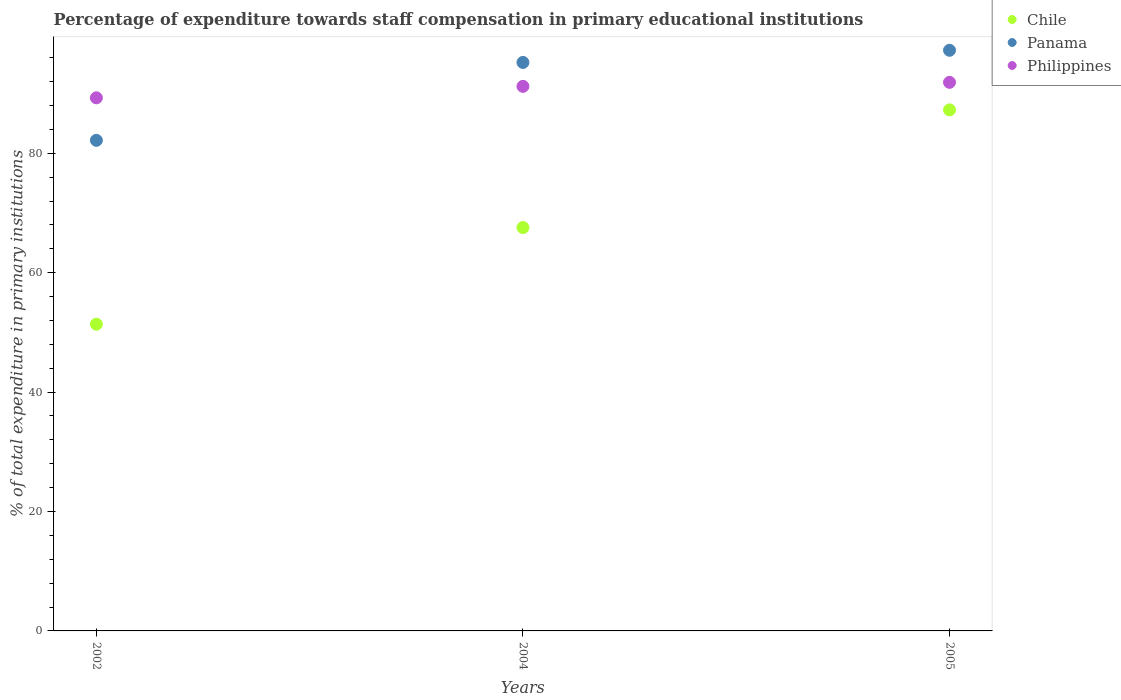How many different coloured dotlines are there?
Your answer should be compact. 3. What is the percentage of expenditure towards staff compensation in Chile in 2004?
Give a very brief answer. 67.56. Across all years, what is the maximum percentage of expenditure towards staff compensation in Chile?
Give a very brief answer. 87.26. Across all years, what is the minimum percentage of expenditure towards staff compensation in Philippines?
Your answer should be very brief. 89.28. In which year was the percentage of expenditure towards staff compensation in Chile maximum?
Provide a short and direct response. 2005. What is the total percentage of expenditure towards staff compensation in Panama in the graph?
Keep it short and to the point. 274.62. What is the difference between the percentage of expenditure towards staff compensation in Panama in 2004 and that in 2005?
Offer a very short reply. -2.04. What is the difference between the percentage of expenditure towards staff compensation in Philippines in 2004 and the percentage of expenditure towards staff compensation in Chile in 2005?
Keep it short and to the point. 3.94. What is the average percentage of expenditure towards staff compensation in Chile per year?
Your answer should be compact. 68.73. In the year 2002, what is the difference between the percentage of expenditure towards staff compensation in Panama and percentage of expenditure towards staff compensation in Philippines?
Make the answer very short. -7.12. What is the ratio of the percentage of expenditure towards staff compensation in Chile in 2004 to that in 2005?
Give a very brief answer. 0.77. Is the percentage of expenditure towards staff compensation in Philippines in 2004 less than that in 2005?
Provide a succinct answer. Yes. What is the difference between the highest and the second highest percentage of expenditure towards staff compensation in Chile?
Make the answer very short. 19.71. What is the difference between the highest and the lowest percentage of expenditure towards staff compensation in Chile?
Ensure brevity in your answer.  35.89. Is the sum of the percentage of expenditure towards staff compensation in Panama in 2002 and 2004 greater than the maximum percentage of expenditure towards staff compensation in Chile across all years?
Your response must be concise. Yes. Is it the case that in every year, the sum of the percentage of expenditure towards staff compensation in Philippines and percentage of expenditure towards staff compensation in Panama  is greater than the percentage of expenditure towards staff compensation in Chile?
Offer a terse response. Yes. Is the percentage of expenditure towards staff compensation in Philippines strictly greater than the percentage of expenditure towards staff compensation in Panama over the years?
Make the answer very short. No. Is the percentage of expenditure towards staff compensation in Chile strictly less than the percentage of expenditure towards staff compensation in Philippines over the years?
Provide a succinct answer. Yes. How many years are there in the graph?
Make the answer very short. 3. What is the difference between two consecutive major ticks on the Y-axis?
Offer a very short reply. 20. Does the graph contain any zero values?
Provide a short and direct response. No. Where does the legend appear in the graph?
Offer a very short reply. Top right. How many legend labels are there?
Your answer should be compact. 3. What is the title of the graph?
Give a very brief answer. Percentage of expenditure towards staff compensation in primary educational institutions. Does "Korea (Republic)" appear as one of the legend labels in the graph?
Keep it short and to the point. No. What is the label or title of the X-axis?
Your answer should be very brief. Years. What is the label or title of the Y-axis?
Your answer should be very brief. % of total expenditure in primary institutions. What is the % of total expenditure in primary institutions of Chile in 2002?
Provide a succinct answer. 51.37. What is the % of total expenditure in primary institutions of Panama in 2002?
Offer a very short reply. 82.16. What is the % of total expenditure in primary institutions in Philippines in 2002?
Your response must be concise. 89.28. What is the % of total expenditure in primary institutions of Chile in 2004?
Make the answer very short. 67.56. What is the % of total expenditure in primary institutions of Panama in 2004?
Give a very brief answer. 95.21. What is the % of total expenditure in primary institutions in Philippines in 2004?
Give a very brief answer. 91.2. What is the % of total expenditure in primary institutions of Chile in 2005?
Your answer should be compact. 87.26. What is the % of total expenditure in primary institutions of Panama in 2005?
Give a very brief answer. 97.25. What is the % of total expenditure in primary institutions in Philippines in 2005?
Your answer should be compact. 91.88. Across all years, what is the maximum % of total expenditure in primary institutions of Chile?
Give a very brief answer. 87.26. Across all years, what is the maximum % of total expenditure in primary institutions in Panama?
Provide a short and direct response. 97.25. Across all years, what is the maximum % of total expenditure in primary institutions of Philippines?
Provide a succinct answer. 91.88. Across all years, what is the minimum % of total expenditure in primary institutions in Chile?
Provide a short and direct response. 51.37. Across all years, what is the minimum % of total expenditure in primary institutions in Panama?
Offer a very short reply. 82.16. Across all years, what is the minimum % of total expenditure in primary institutions in Philippines?
Provide a succinct answer. 89.28. What is the total % of total expenditure in primary institutions of Chile in the graph?
Offer a very short reply. 206.19. What is the total % of total expenditure in primary institutions of Panama in the graph?
Keep it short and to the point. 274.62. What is the total % of total expenditure in primary institutions in Philippines in the graph?
Ensure brevity in your answer.  272.36. What is the difference between the % of total expenditure in primary institutions of Chile in 2002 and that in 2004?
Give a very brief answer. -16.19. What is the difference between the % of total expenditure in primary institutions of Panama in 2002 and that in 2004?
Your answer should be very brief. -13.04. What is the difference between the % of total expenditure in primary institutions of Philippines in 2002 and that in 2004?
Provide a short and direct response. -1.92. What is the difference between the % of total expenditure in primary institutions of Chile in 2002 and that in 2005?
Provide a succinct answer. -35.89. What is the difference between the % of total expenditure in primary institutions in Panama in 2002 and that in 2005?
Provide a short and direct response. -15.08. What is the difference between the % of total expenditure in primary institutions in Philippines in 2002 and that in 2005?
Offer a very short reply. -2.59. What is the difference between the % of total expenditure in primary institutions of Chile in 2004 and that in 2005?
Ensure brevity in your answer.  -19.71. What is the difference between the % of total expenditure in primary institutions in Panama in 2004 and that in 2005?
Make the answer very short. -2.04. What is the difference between the % of total expenditure in primary institutions in Philippines in 2004 and that in 2005?
Make the answer very short. -0.67. What is the difference between the % of total expenditure in primary institutions of Chile in 2002 and the % of total expenditure in primary institutions of Panama in 2004?
Keep it short and to the point. -43.84. What is the difference between the % of total expenditure in primary institutions in Chile in 2002 and the % of total expenditure in primary institutions in Philippines in 2004?
Provide a short and direct response. -39.83. What is the difference between the % of total expenditure in primary institutions in Panama in 2002 and the % of total expenditure in primary institutions in Philippines in 2004?
Your answer should be compact. -9.04. What is the difference between the % of total expenditure in primary institutions in Chile in 2002 and the % of total expenditure in primary institutions in Panama in 2005?
Ensure brevity in your answer.  -45.88. What is the difference between the % of total expenditure in primary institutions in Chile in 2002 and the % of total expenditure in primary institutions in Philippines in 2005?
Make the answer very short. -40.5. What is the difference between the % of total expenditure in primary institutions of Panama in 2002 and the % of total expenditure in primary institutions of Philippines in 2005?
Offer a terse response. -9.71. What is the difference between the % of total expenditure in primary institutions in Chile in 2004 and the % of total expenditure in primary institutions in Panama in 2005?
Your answer should be very brief. -29.69. What is the difference between the % of total expenditure in primary institutions in Chile in 2004 and the % of total expenditure in primary institutions in Philippines in 2005?
Keep it short and to the point. -24.32. What is the difference between the % of total expenditure in primary institutions of Panama in 2004 and the % of total expenditure in primary institutions of Philippines in 2005?
Keep it short and to the point. 3.33. What is the average % of total expenditure in primary institutions in Chile per year?
Provide a short and direct response. 68.73. What is the average % of total expenditure in primary institutions of Panama per year?
Offer a very short reply. 91.54. What is the average % of total expenditure in primary institutions of Philippines per year?
Keep it short and to the point. 90.79. In the year 2002, what is the difference between the % of total expenditure in primary institutions of Chile and % of total expenditure in primary institutions of Panama?
Offer a terse response. -30.79. In the year 2002, what is the difference between the % of total expenditure in primary institutions of Chile and % of total expenditure in primary institutions of Philippines?
Give a very brief answer. -37.91. In the year 2002, what is the difference between the % of total expenditure in primary institutions in Panama and % of total expenditure in primary institutions in Philippines?
Offer a very short reply. -7.12. In the year 2004, what is the difference between the % of total expenditure in primary institutions of Chile and % of total expenditure in primary institutions of Panama?
Keep it short and to the point. -27.65. In the year 2004, what is the difference between the % of total expenditure in primary institutions in Chile and % of total expenditure in primary institutions in Philippines?
Provide a succinct answer. -23.65. In the year 2004, what is the difference between the % of total expenditure in primary institutions of Panama and % of total expenditure in primary institutions of Philippines?
Your answer should be very brief. 4. In the year 2005, what is the difference between the % of total expenditure in primary institutions in Chile and % of total expenditure in primary institutions in Panama?
Give a very brief answer. -9.99. In the year 2005, what is the difference between the % of total expenditure in primary institutions of Chile and % of total expenditure in primary institutions of Philippines?
Your answer should be compact. -4.61. In the year 2005, what is the difference between the % of total expenditure in primary institutions of Panama and % of total expenditure in primary institutions of Philippines?
Keep it short and to the point. 5.37. What is the ratio of the % of total expenditure in primary institutions of Chile in 2002 to that in 2004?
Your answer should be compact. 0.76. What is the ratio of the % of total expenditure in primary institutions of Panama in 2002 to that in 2004?
Offer a very short reply. 0.86. What is the ratio of the % of total expenditure in primary institutions of Philippines in 2002 to that in 2004?
Ensure brevity in your answer.  0.98. What is the ratio of the % of total expenditure in primary institutions of Chile in 2002 to that in 2005?
Offer a terse response. 0.59. What is the ratio of the % of total expenditure in primary institutions in Panama in 2002 to that in 2005?
Your response must be concise. 0.84. What is the ratio of the % of total expenditure in primary institutions in Philippines in 2002 to that in 2005?
Provide a short and direct response. 0.97. What is the ratio of the % of total expenditure in primary institutions of Chile in 2004 to that in 2005?
Make the answer very short. 0.77. What is the ratio of the % of total expenditure in primary institutions in Panama in 2004 to that in 2005?
Your answer should be very brief. 0.98. What is the difference between the highest and the second highest % of total expenditure in primary institutions in Chile?
Offer a terse response. 19.71. What is the difference between the highest and the second highest % of total expenditure in primary institutions of Panama?
Offer a very short reply. 2.04. What is the difference between the highest and the second highest % of total expenditure in primary institutions of Philippines?
Provide a succinct answer. 0.67. What is the difference between the highest and the lowest % of total expenditure in primary institutions in Chile?
Ensure brevity in your answer.  35.89. What is the difference between the highest and the lowest % of total expenditure in primary institutions in Panama?
Ensure brevity in your answer.  15.08. What is the difference between the highest and the lowest % of total expenditure in primary institutions of Philippines?
Give a very brief answer. 2.59. 